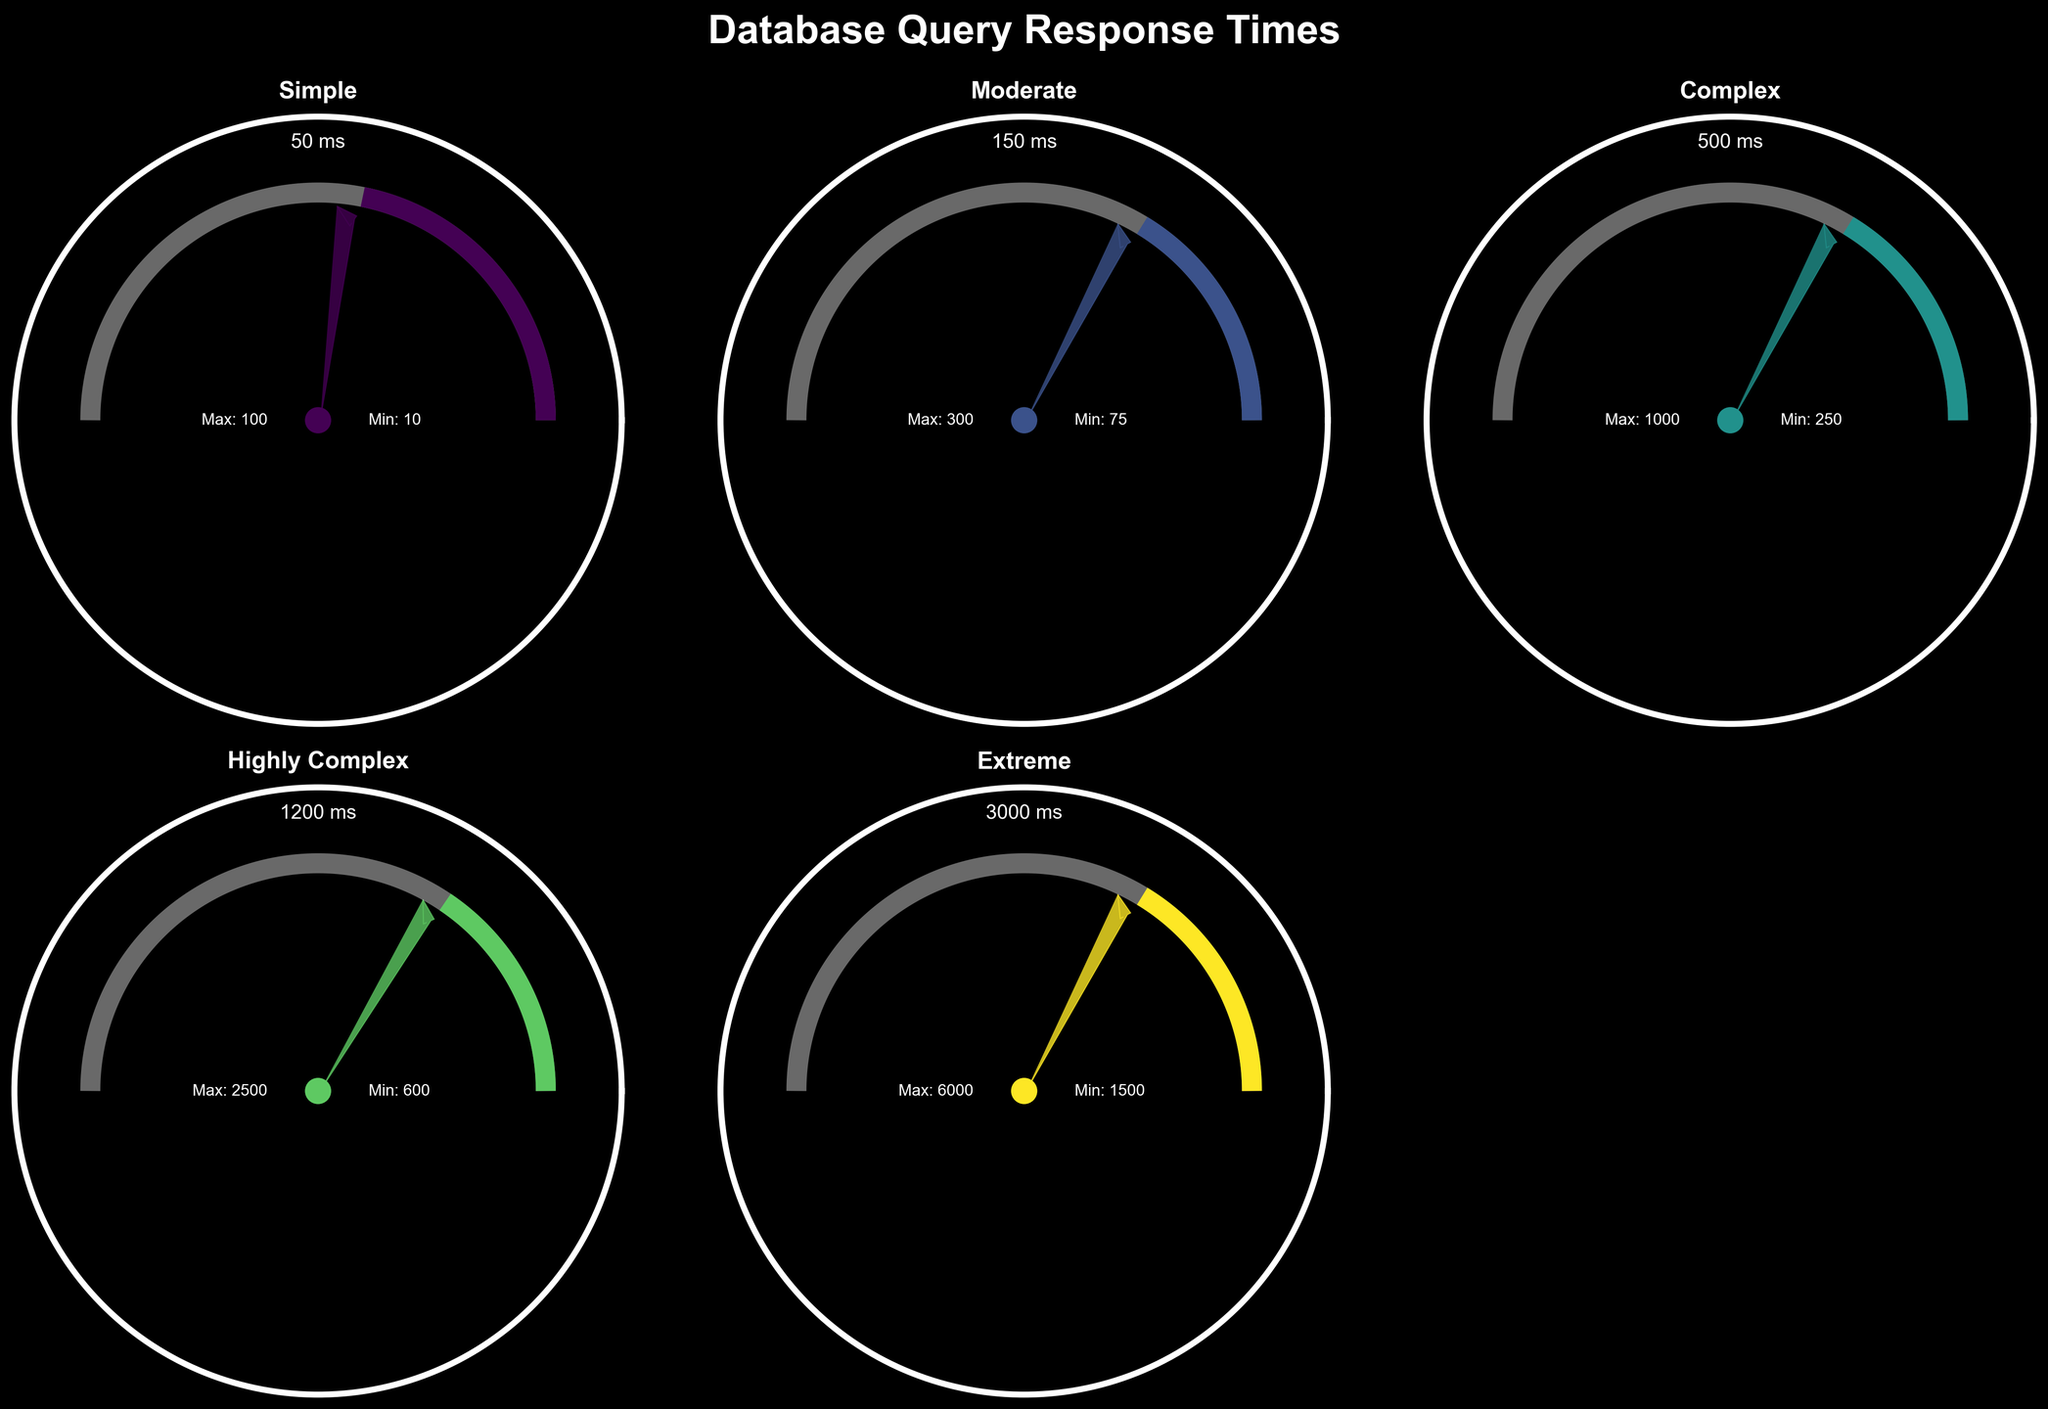How many levels of query complexity are shown in the figure? The figure depicts gauge charts for each query complexity level. Count the individual gauges to determine the number of complexity levels.
Answer: 5 What is the title of the figure? The title is prominently displayed at the top of the figure in a larger font size.
Answer: Database Query Response Times What is the response time for a moderate complexity query? The text near the center of the gauge for moderate complexity shows the exact value in milliseconds.
Answer: 150 ms What is the color used for the simple query complexity gauge? The gauge color information can be discerned by looking at the colored segment and its legend (if any). Identify the color used in that chart.
Answer: Cannot be determined from text description Which query complexity shows the highest response time? Observe the gauge indicators and the text displaying response times for all complexities. The gauge with the highest value points to the answer.
Answer: Extreme What is the ratio of the response time of complex to simple queries? Take the response times for both complex (500 ms) and simple (50 ms) queries and divide the complex query response time by the simple query response time to get the ratio: 500 / 50.
Answer: 10 How does the response time of highly complex queries compare to moderate ones? Compare the response times given (150 ms for moderate and 1200 ms for highly complex). Identify whether the highly complex is greater than, less than, or equal to moderate.
Answer: Highly complex is greater What are the minimum and maximum response times for a complex query? The minimum and maximum values are indicated as text annotations near the respective gauge. For complex queries, read these annotations.
Answer: 250 ms and 1000 ms Which query complexity gauge has the smallest range between min and max times? The range can be calculated by subtracting the min time from the max time for each complexity. Compare these ranges to find the smallest.
Answer: Simple What is the needle position on the gauge for extreme queries relative to its overall range? To assess the needle position: first, calculate the value range (max - min), then determine the normalized position of the needle using (response - min) / (max - min). For extreme, it’s (3000 - 1500) / (6000 - 1500) = 0.33.
Answer: 0.33 